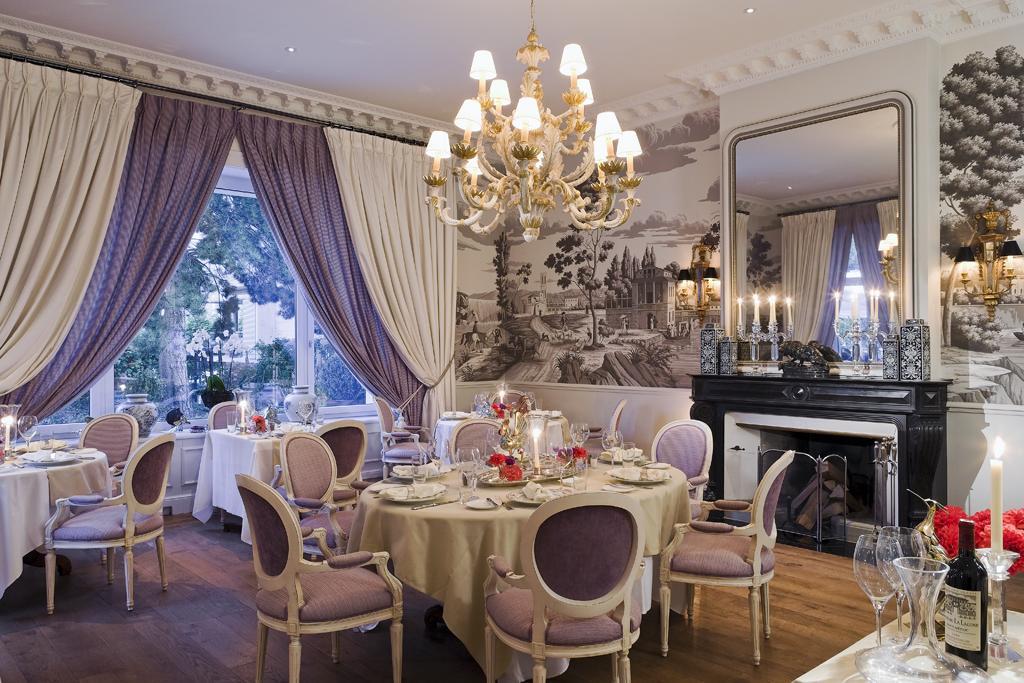In one or two sentences, can you explain what this image depicts? In this image we can see tables, chairs, lights, plates, glasses, bottle, mirror, candle, wall paintings, curtains and other objects. In the background of the image there is a glass window. Behind the glass window there are trees and the sky. At the top of the image there is the ceiling with lights and chandelier. At the bottom of the image there is the floor. 